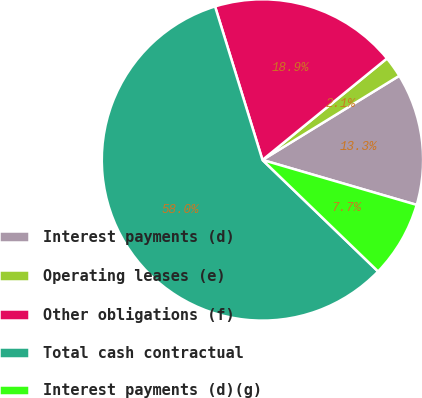Convert chart to OTSL. <chart><loc_0><loc_0><loc_500><loc_500><pie_chart><fcel>Interest payments (d)<fcel>Operating leases (e)<fcel>Other obligations (f)<fcel>Total cash contractual<fcel>Interest payments (d)(g)<nl><fcel>13.29%<fcel>2.11%<fcel>18.88%<fcel>58.02%<fcel>7.7%<nl></chart> 